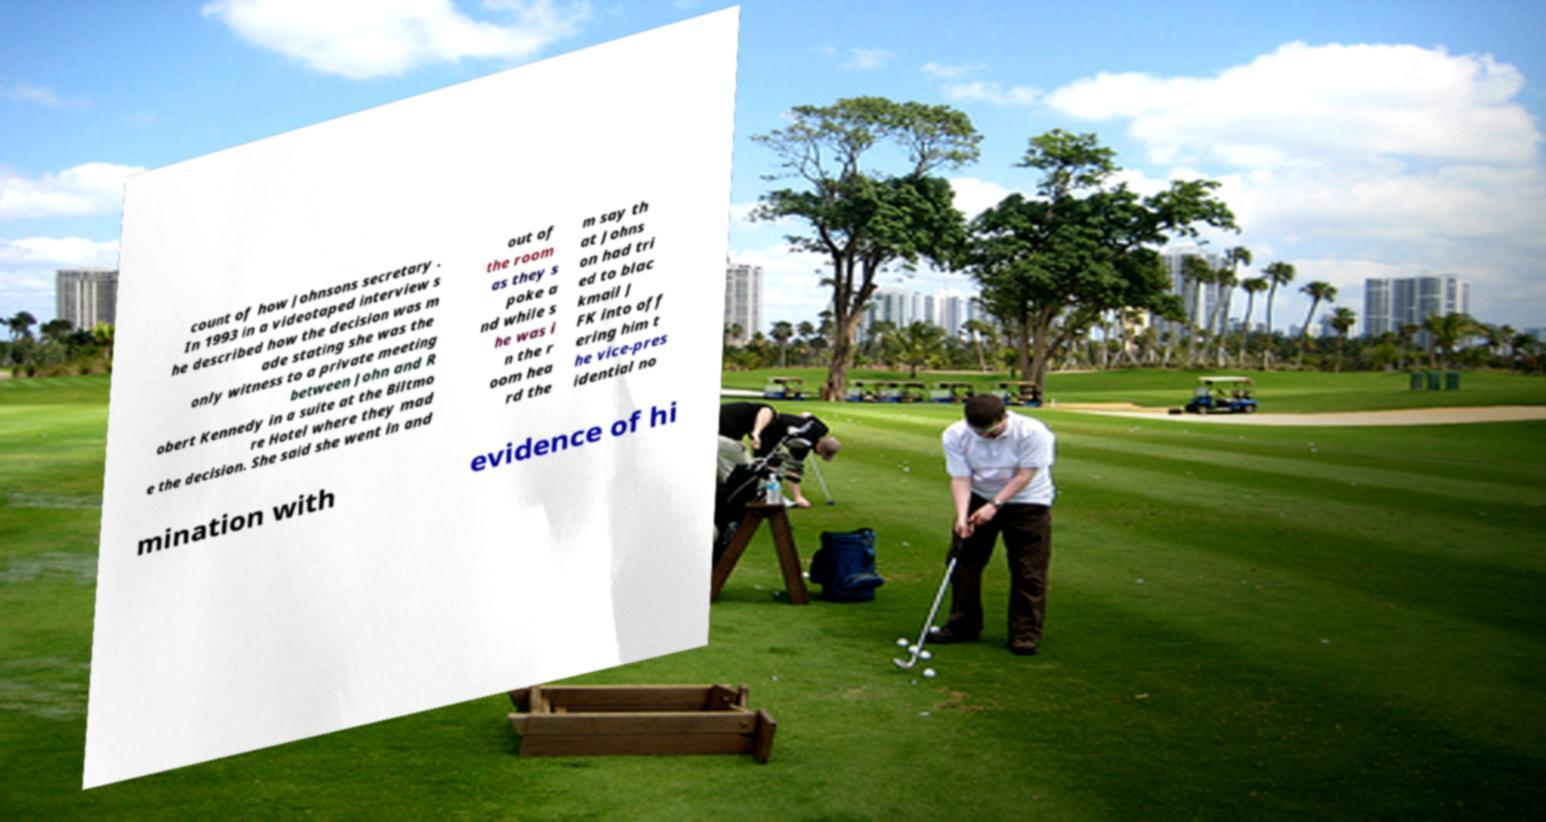There's text embedded in this image that I need extracted. Can you transcribe it verbatim? count of how Johnsons secretary . In 1993 in a videotaped interview s he described how the decision was m ade stating she was the only witness to a private meeting between John and R obert Kennedy in a suite at the Biltmo re Hotel where they mad e the decision. She said she went in and out of the room as they s poke a nd while s he was i n the r oom hea rd the m say th at Johns on had tri ed to blac kmail J FK into off ering him t he vice-pres idential no mination with evidence of hi 